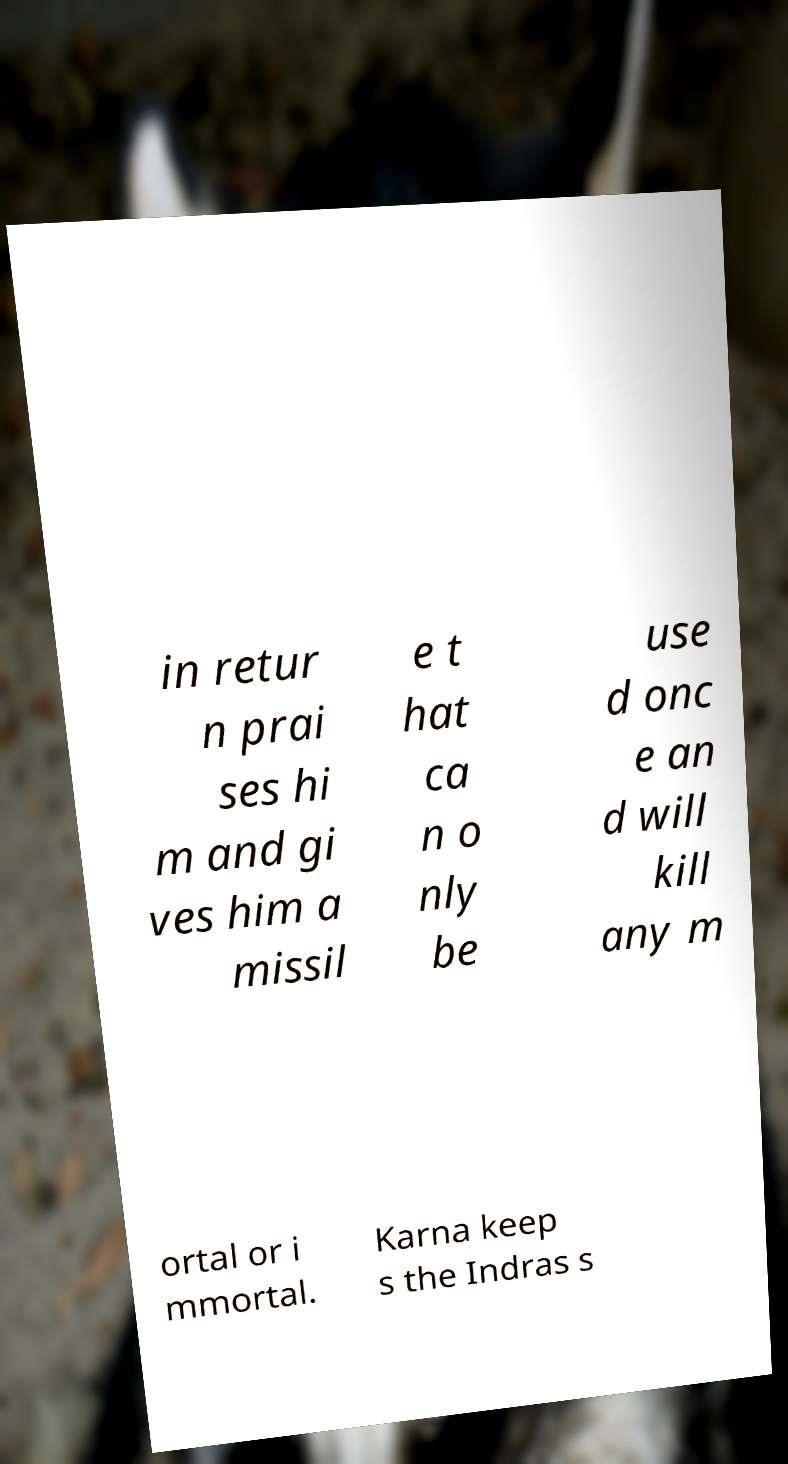I need the written content from this picture converted into text. Can you do that? in retur n prai ses hi m and gi ves him a missil e t hat ca n o nly be use d onc e an d will kill any m ortal or i mmortal. Karna keep s the Indras s 